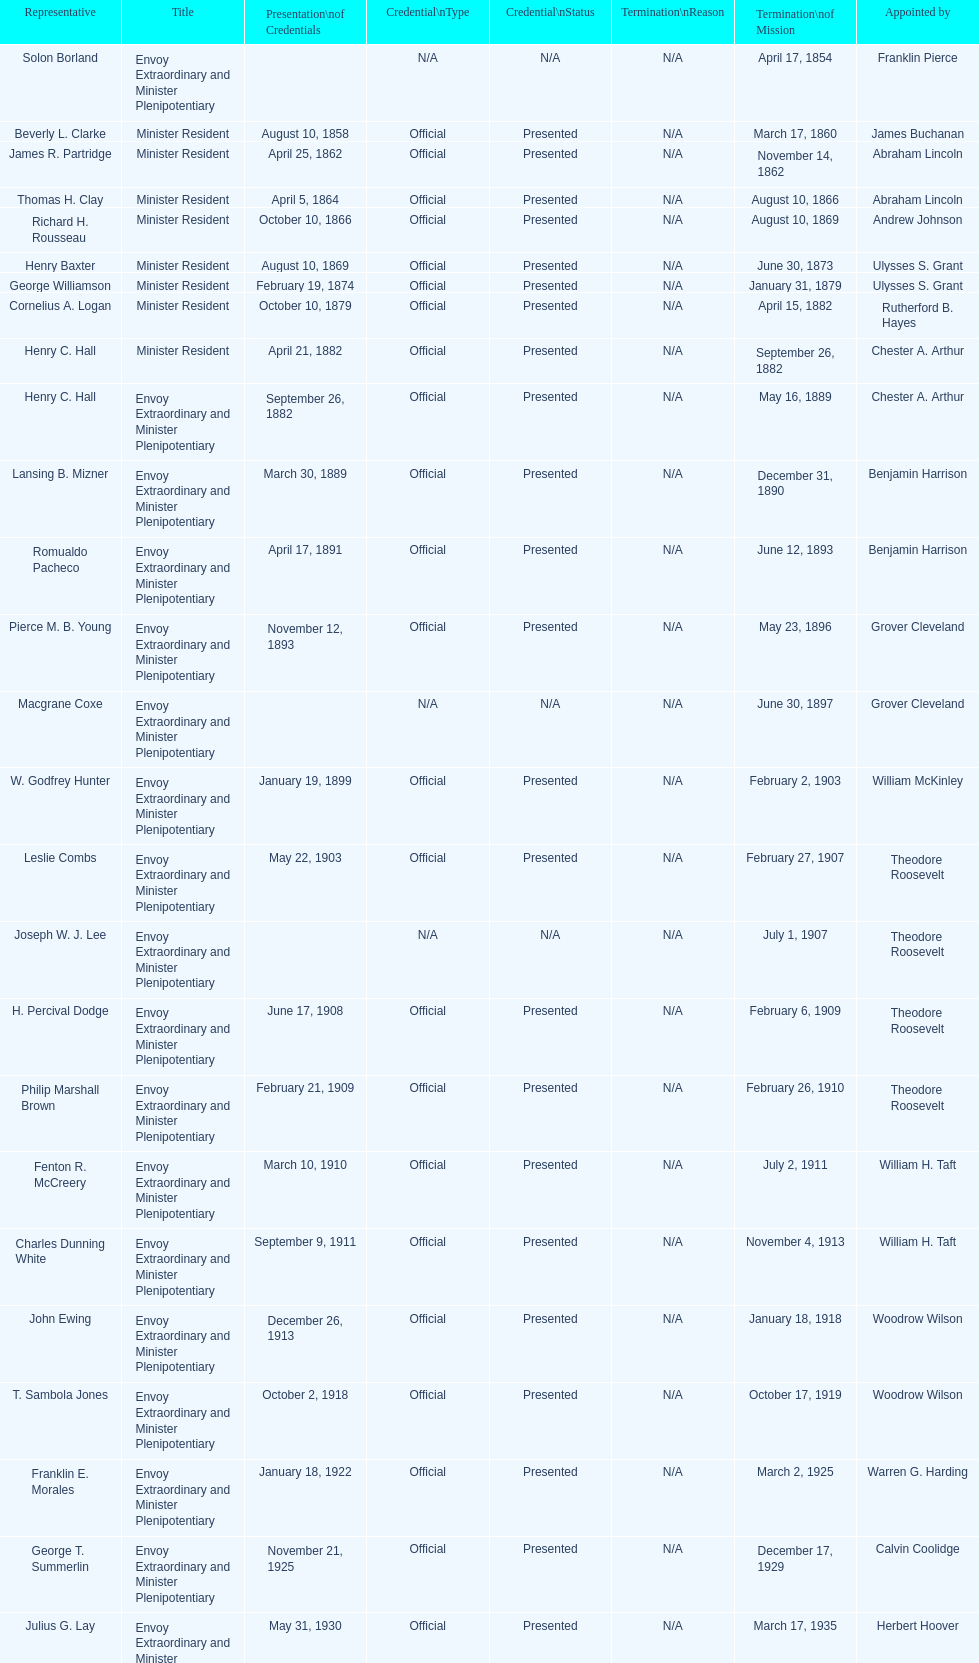Which date is below april 17, 1854 March 17, 1860. 